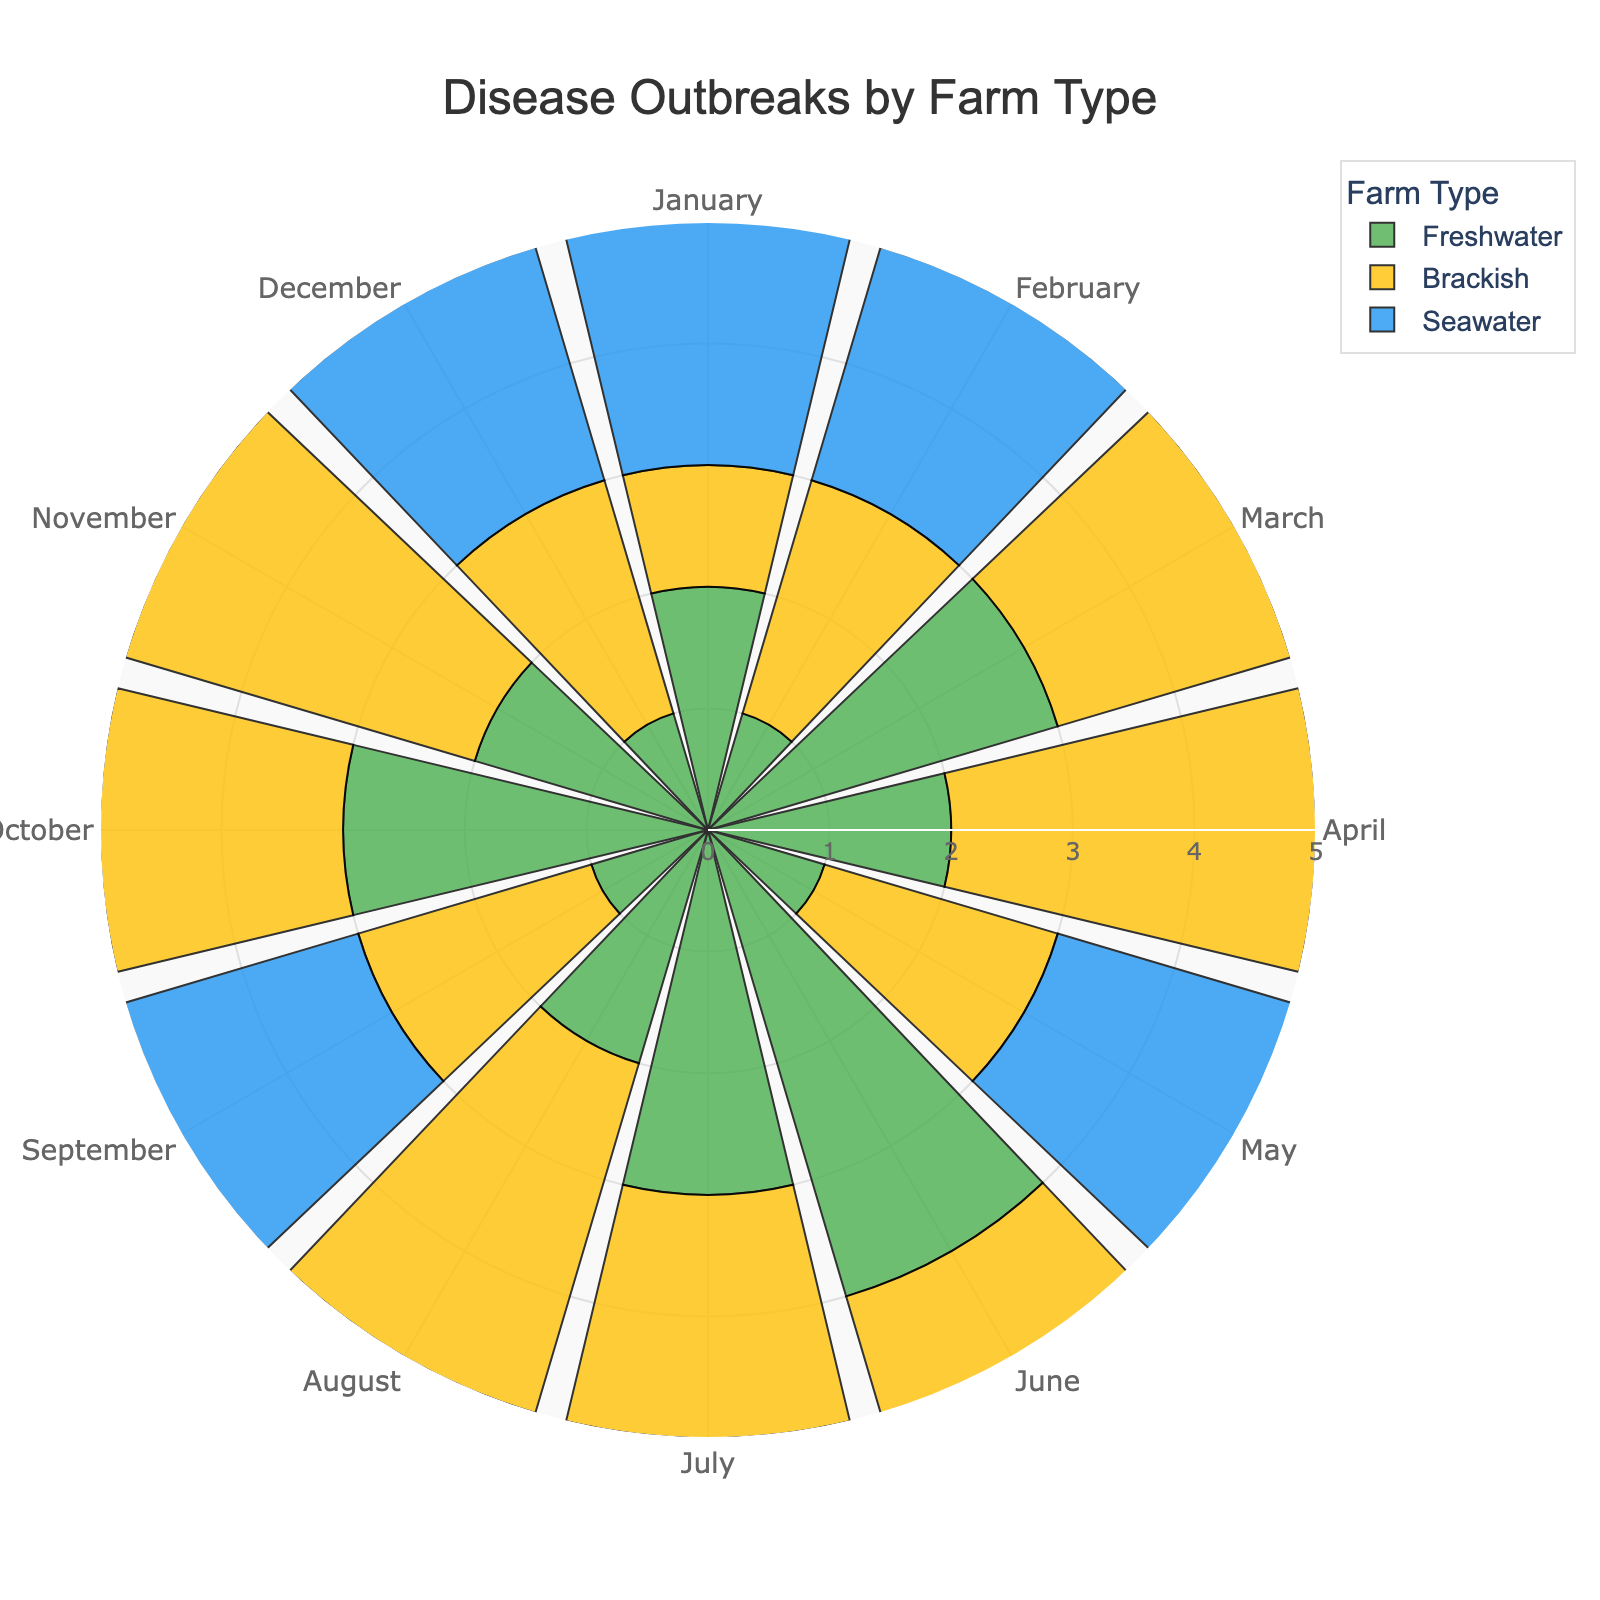What is the title of the rose chart? The title is usually displayed prominently in the chart's layout.
Answer: Disease Outbreaks by Farm Type How many months show data for each farm type? The chart consists of 12 different segments representing each month from January to December.
Answer: 12 Which farm type had the highest frequency of disease outbreaks in July? In July, comparing the lengths of the bars, the Freshwater and Seawater farm types both had the highest frequency.
Answer: Freshwater and Seawater What is the average frequency of disease outbreaks for Seawater farms across the year? The frequencies for Seawater farms are summed up (3+2+1+4+3+2+3+4+2+3+1+2 = 32). Dividing by 12 months gives 32/12.
Answer: 2.67 Which months had the same frequency of disease outbreaks for Brackish farms? Checking the bars for Brackish farms, March, September, and November all have a frequency of 2.
Answer: March, September, and November In which month did Freshwater farms experience the fewest disease outbreaks? Observing the shortest bar for Freshwater, January, February, May, September, and December all have a frequency of 1.
Answer: January, February, May, September, and December Which farm type had the most consistent (least variable) frequency of disease outbreaks throughout the year? The farm type with bars of similar lengths is the Brackish farm type.
Answer: Brackish What's the difference in the highest frequency of disease outbreaks between Freshwater and Seawater farms? The highest frequencies are 4 for both Freshwater and Seawater farms. The difference is 4 - 4 = 0.
Answer: 0 Which farm type had the lowest frequency of disease outbreaks in April? By comparing the bars for April, the Seawater farm type has the highest frequency of 4, making Freshwater and Brackish with 2 and 3 respectively lower.
Answer: Freshwater 